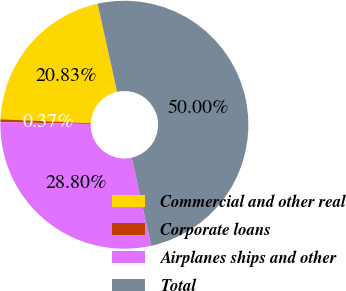Convert chart to OTSL. <chart><loc_0><loc_0><loc_500><loc_500><pie_chart><fcel>Commercial and other real<fcel>Corporate loans<fcel>Airplanes ships and other<fcel>Total<nl><fcel>20.83%<fcel>0.37%<fcel>28.8%<fcel>50.0%<nl></chart> 